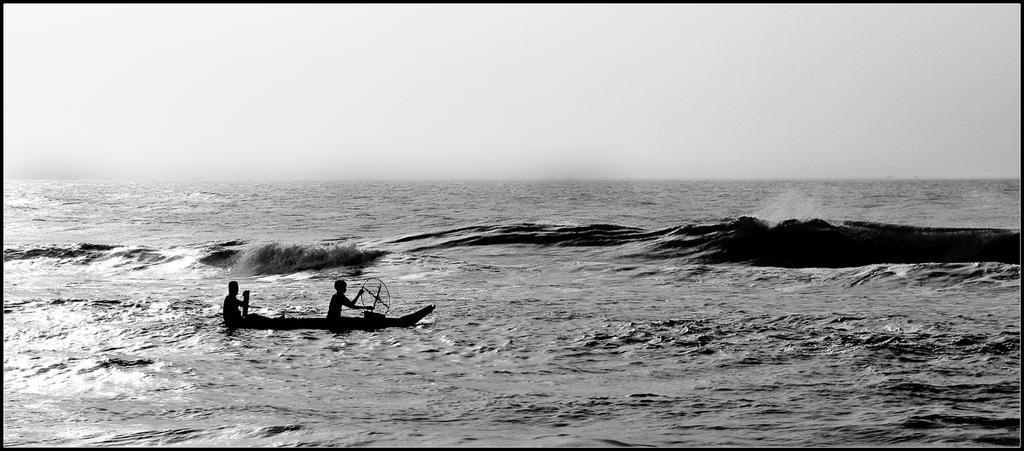How would you summarize this image in a sentence or two? This picture consists of sea and I can see tides of sea visible in the middle and I can see two persons sitting on boat and the boat is visible on sea,at the top I can see the sky. 